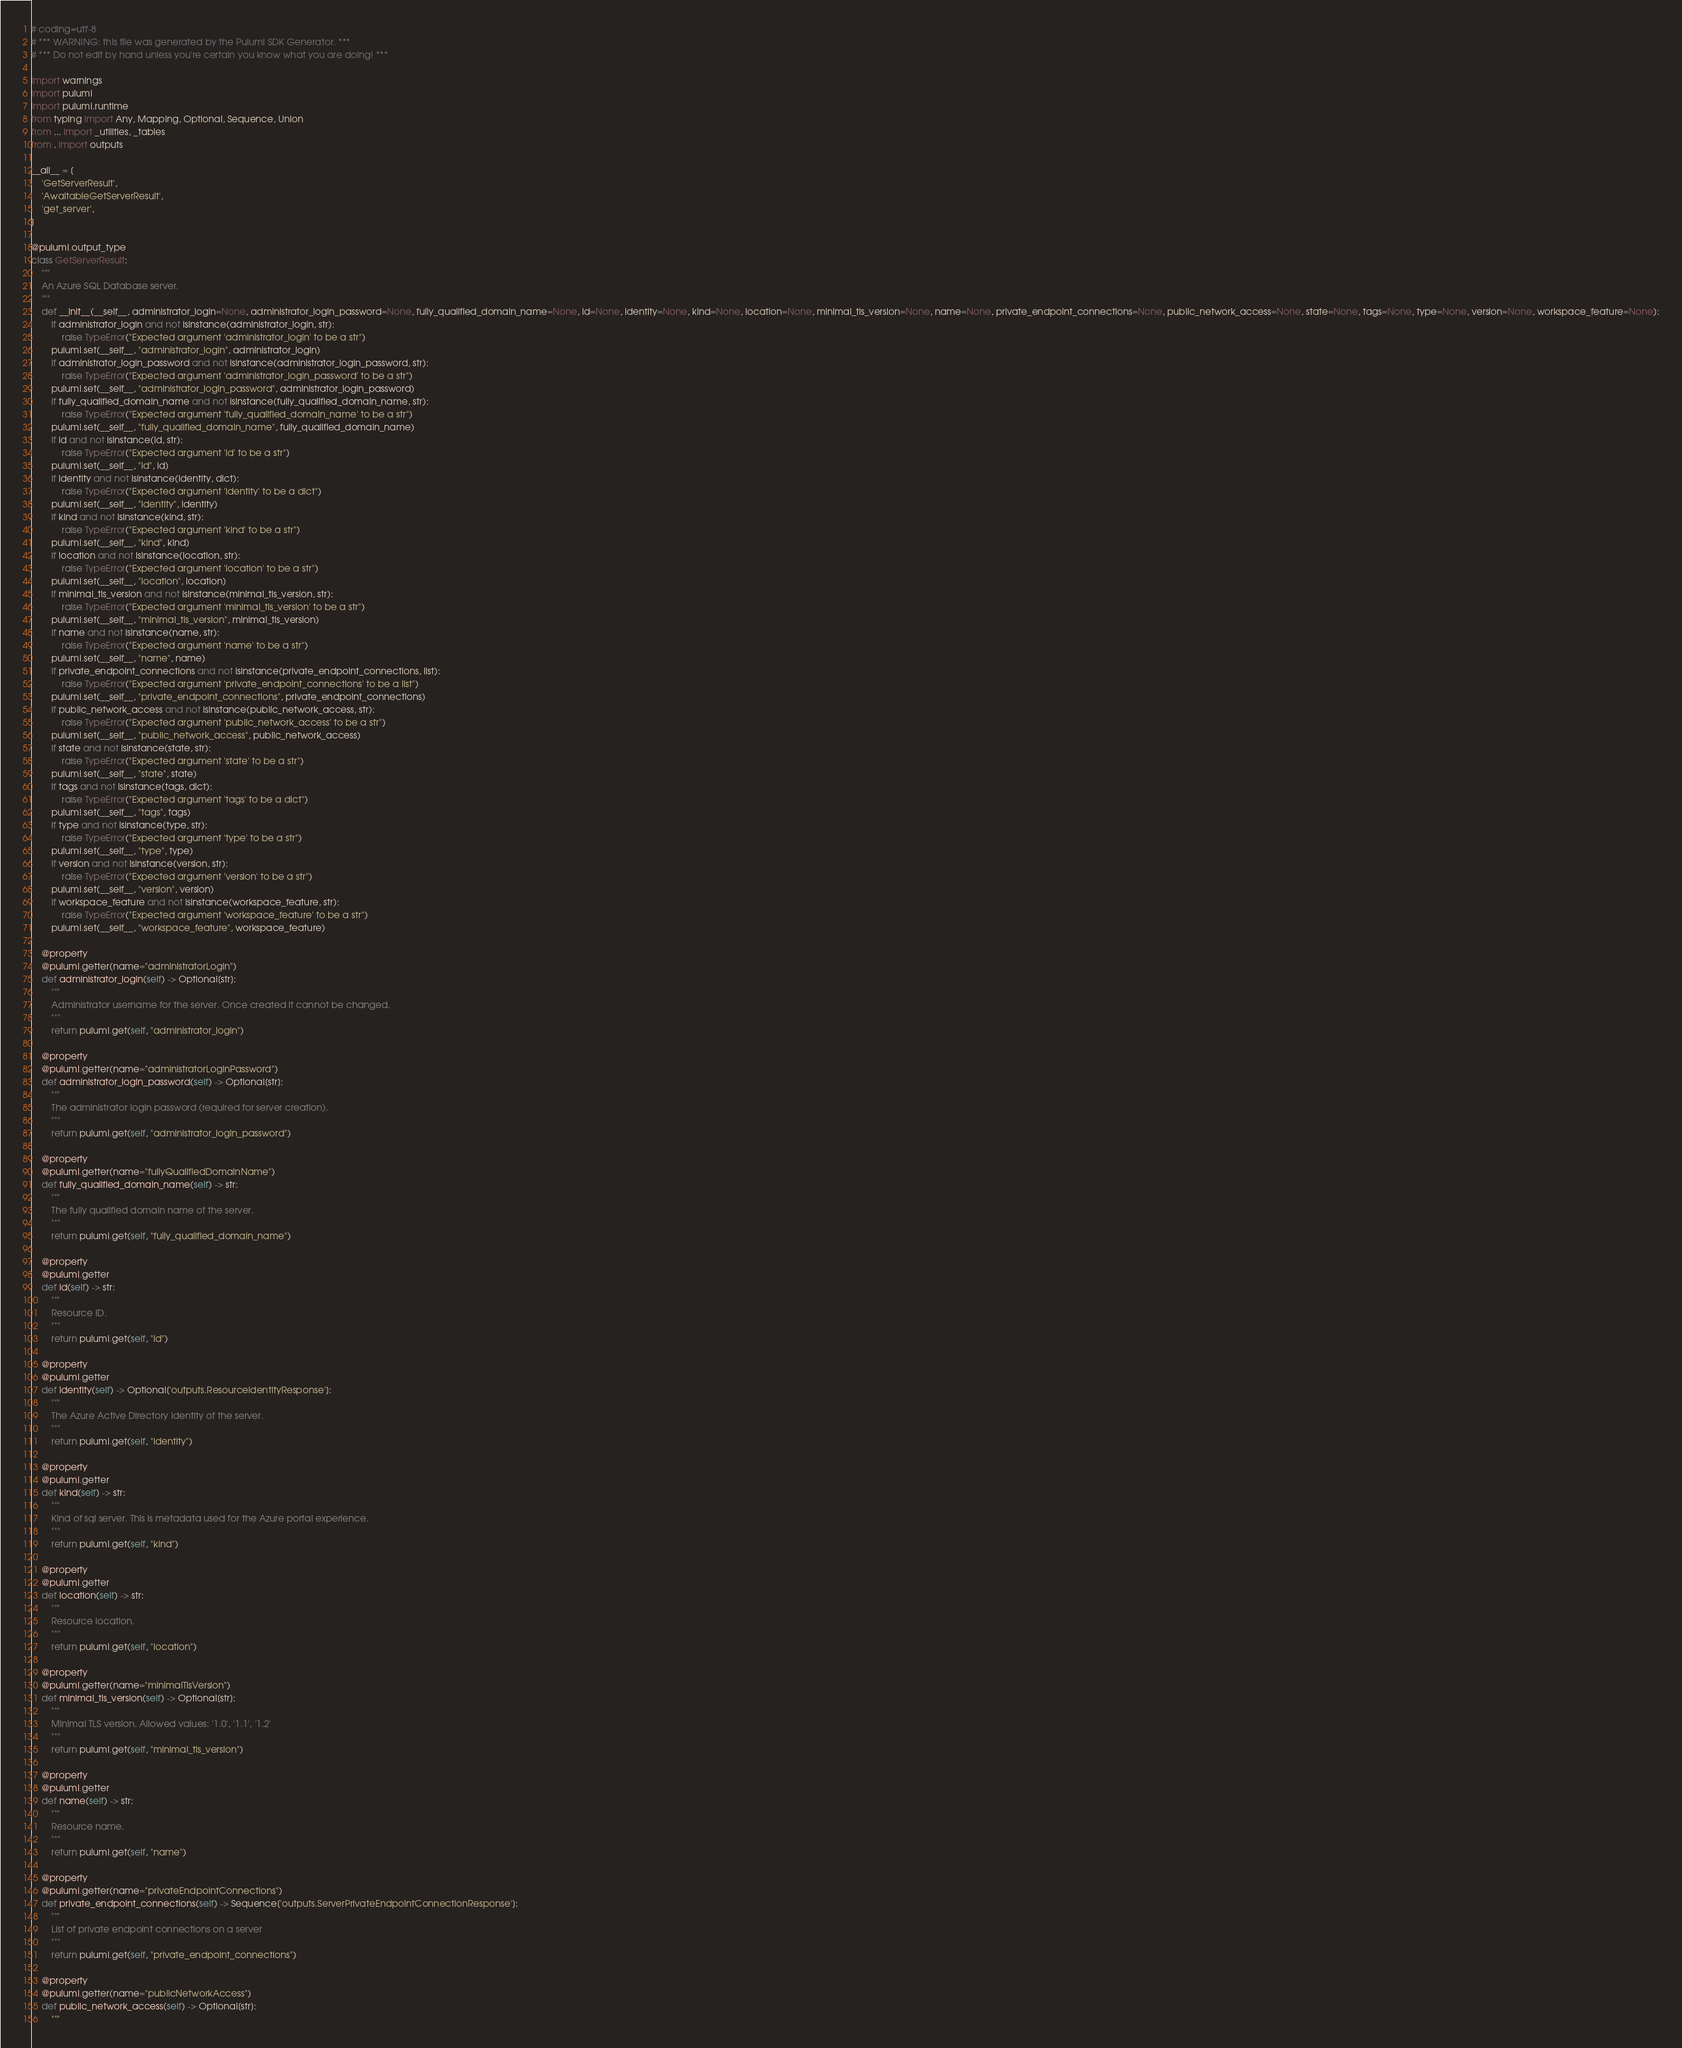<code> <loc_0><loc_0><loc_500><loc_500><_Python_># coding=utf-8
# *** WARNING: this file was generated by the Pulumi SDK Generator. ***
# *** Do not edit by hand unless you're certain you know what you are doing! ***

import warnings
import pulumi
import pulumi.runtime
from typing import Any, Mapping, Optional, Sequence, Union
from ... import _utilities, _tables
from . import outputs

__all__ = [
    'GetServerResult',
    'AwaitableGetServerResult',
    'get_server',
]

@pulumi.output_type
class GetServerResult:
    """
    An Azure SQL Database server.
    """
    def __init__(__self__, administrator_login=None, administrator_login_password=None, fully_qualified_domain_name=None, id=None, identity=None, kind=None, location=None, minimal_tls_version=None, name=None, private_endpoint_connections=None, public_network_access=None, state=None, tags=None, type=None, version=None, workspace_feature=None):
        if administrator_login and not isinstance(administrator_login, str):
            raise TypeError("Expected argument 'administrator_login' to be a str")
        pulumi.set(__self__, "administrator_login", administrator_login)
        if administrator_login_password and not isinstance(administrator_login_password, str):
            raise TypeError("Expected argument 'administrator_login_password' to be a str")
        pulumi.set(__self__, "administrator_login_password", administrator_login_password)
        if fully_qualified_domain_name and not isinstance(fully_qualified_domain_name, str):
            raise TypeError("Expected argument 'fully_qualified_domain_name' to be a str")
        pulumi.set(__self__, "fully_qualified_domain_name", fully_qualified_domain_name)
        if id and not isinstance(id, str):
            raise TypeError("Expected argument 'id' to be a str")
        pulumi.set(__self__, "id", id)
        if identity and not isinstance(identity, dict):
            raise TypeError("Expected argument 'identity' to be a dict")
        pulumi.set(__self__, "identity", identity)
        if kind and not isinstance(kind, str):
            raise TypeError("Expected argument 'kind' to be a str")
        pulumi.set(__self__, "kind", kind)
        if location and not isinstance(location, str):
            raise TypeError("Expected argument 'location' to be a str")
        pulumi.set(__self__, "location", location)
        if minimal_tls_version and not isinstance(minimal_tls_version, str):
            raise TypeError("Expected argument 'minimal_tls_version' to be a str")
        pulumi.set(__self__, "minimal_tls_version", minimal_tls_version)
        if name and not isinstance(name, str):
            raise TypeError("Expected argument 'name' to be a str")
        pulumi.set(__self__, "name", name)
        if private_endpoint_connections and not isinstance(private_endpoint_connections, list):
            raise TypeError("Expected argument 'private_endpoint_connections' to be a list")
        pulumi.set(__self__, "private_endpoint_connections", private_endpoint_connections)
        if public_network_access and not isinstance(public_network_access, str):
            raise TypeError("Expected argument 'public_network_access' to be a str")
        pulumi.set(__self__, "public_network_access", public_network_access)
        if state and not isinstance(state, str):
            raise TypeError("Expected argument 'state' to be a str")
        pulumi.set(__self__, "state", state)
        if tags and not isinstance(tags, dict):
            raise TypeError("Expected argument 'tags' to be a dict")
        pulumi.set(__self__, "tags", tags)
        if type and not isinstance(type, str):
            raise TypeError("Expected argument 'type' to be a str")
        pulumi.set(__self__, "type", type)
        if version and not isinstance(version, str):
            raise TypeError("Expected argument 'version' to be a str")
        pulumi.set(__self__, "version", version)
        if workspace_feature and not isinstance(workspace_feature, str):
            raise TypeError("Expected argument 'workspace_feature' to be a str")
        pulumi.set(__self__, "workspace_feature", workspace_feature)

    @property
    @pulumi.getter(name="administratorLogin")
    def administrator_login(self) -> Optional[str]:
        """
        Administrator username for the server. Once created it cannot be changed.
        """
        return pulumi.get(self, "administrator_login")

    @property
    @pulumi.getter(name="administratorLoginPassword")
    def administrator_login_password(self) -> Optional[str]:
        """
        The administrator login password (required for server creation).
        """
        return pulumi.get(self, "administrator_login_password")

    @property
    @pulumi.getter(name="fullyQualifiedDomainName")
    def fully_qualified_domain_name(self) -> str:
        """
        The fully qualified domain name of the server.
        """
        return pulumi.get(self, "fully_qualified_domain_name")

    @property
    @pulumi.getter
    def id(self) -> str:
        """
        Resource ID.
        """
        return pulumi.get(self, "id")

    @property
    @pulumi.getter
    def identity(self) -> Optional['outputs.ResourceIdentityResponse']:
        """
        The Azure Active Directory identity of the server.
        """
        return pulumi.get(self, "identity")

    @property
    @pulumi.getter
    def kind(self) -> str:
        """
        Kind of sql server. This is metadata used for the Azure portal experience.
        """
        return pulumi.get(self, "kind")

    @property
    @pulumi.getter
    def location(self) -> str:
        """
        Resource location.
        """
        return pulumi.get(self, "location")

    @property
    @pulumi.getter(name="minimalTlsVersion")
    def minimal_tls_version(self) -> Optional[str]:
        """
        Minimal TLS version. Allowed values: '1.0', '1.1', '1.2'
        """
        return pulumi.get(self, "minimal_tls_version")

    @property
    @pulumi.getter
    def name(self) -> str:
        """
        Resource name.
        """
        return pulumi.get(self, "name")

    @property
    @pulumi.getter(name="privateEndpointConnections")
    def private_endpoint_connections(self) -> Sequence['outputs.ServerPrivateEndpointConnectionResponse']:
        """
        List of private endpoint connections on a server
        """
        return pulumi.get(self, "private_endpoint_connections")

    @property
    @pulumi.getter(name="publicNetworkAccess")
    def public_network_access(self) -> Optional[str]:
        """</code> 